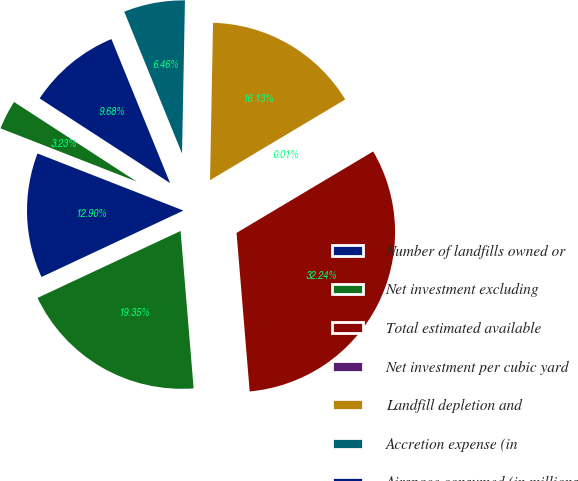<chart> <loc_0><loc_0><loc_500><loc_500><pie_chart><fcel>Number of landfills owned or<fcel>Net investment excluding<fcel>Total estimated available<fcel>Net investment per cubic yard<fcel>Landfill depletion and<fcel>Accretion expense (in<fcel>Airspace consumed (in millions<fcel>Depletion amortization and<nl><fcel>12.9%<fcel>19.35%<fcel>32.24%<fcel>0.01%<fcel>16.13%<fcel>6.46%<fcel>9.68%<fcel>3.23%<nl></chart> 